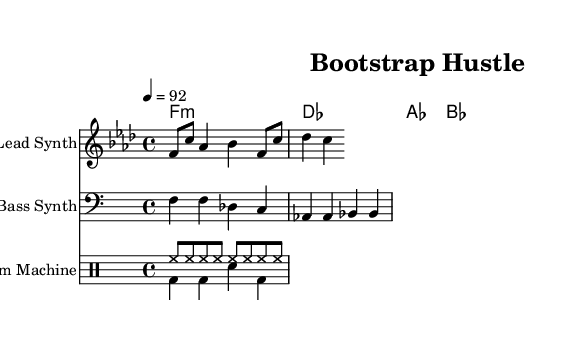What is the key signature of this music? The key signature is F minor, which indicates that it has four flats (B♭, E♭, A♭, and D♭). This can be determined by finding the key signature indicated at the beginning of the staff.
Answer: F minor What is the time signature of this music? The time signature is 4/4, meaning there are four beats in each measure and the quarter note gets one beat. This is indicated at the beginning of the score right after the key signature.
Answer: 4/4 What is the tempo marking for this music? The tempo marking is 92 beats per minute, indicated above the staff as "4 = 92". This means that the quarter note should be played at a speed of 92 beats per minute.
Answer: 92 How many measures are in the melody part? The melody part contains four measures, which can be counted by observing the bar lines dividing the notes on the staff. Each group of notes between the bar lines constitutes a measure.
Answer: 4 What style of music does this sheet represent? The style of music represented is Hip Hop, as indicated by the title "Bootstrap Hustle" and the categorization in the context of self-reliance and entrepreneurship often found in rap songs.
Answer: Hip Hop What instruments are used in this composition? The instruments used are a Lead Synth, Bass Synth, and a Drum Machine, as labeled at the beginning of each staff in the score.
Answer: Lead Synth, Bass Synth, Drum Machine 